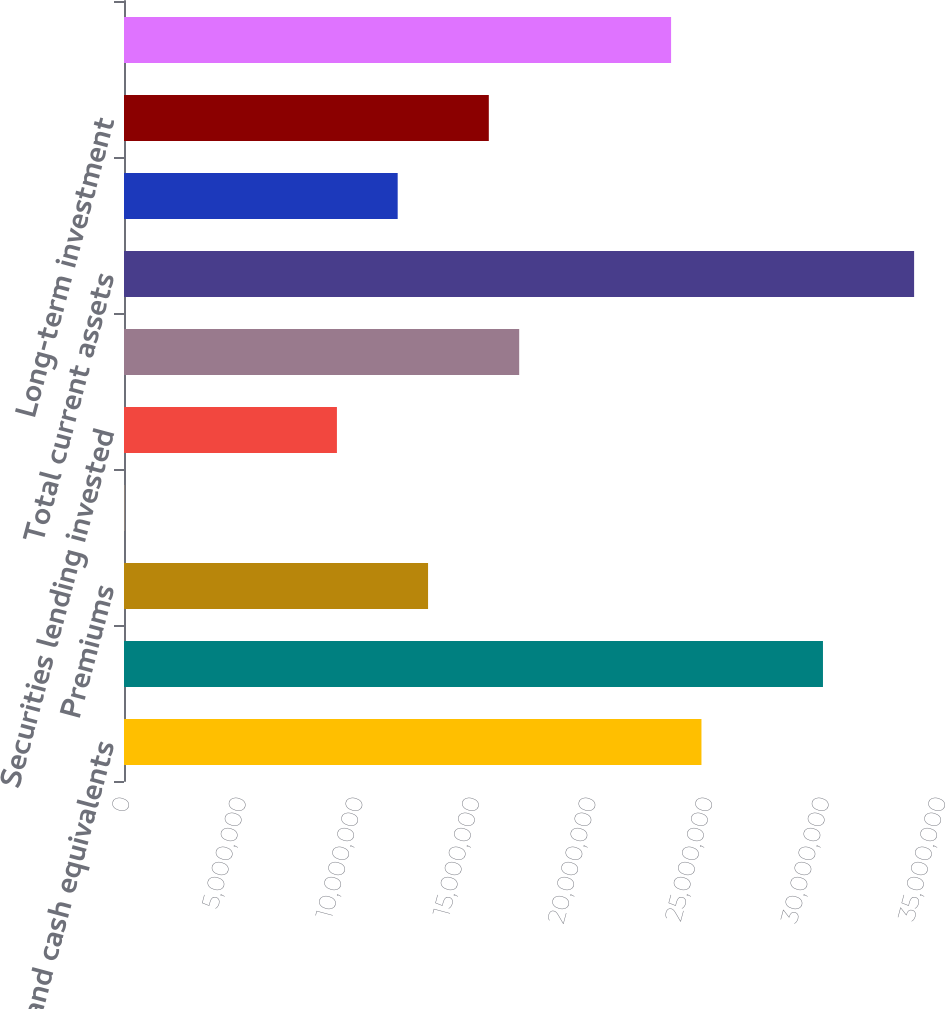Convert chart to OTSL. <chart><loc_0><loc_0><loc_500><loc_500><bar_chart><fcel>Cash and cash equivalents<fcel>Investment securities<fcel>Premiums<fcel>Administrative services fees<fcel>Securities lending invested<fcel>Other current assets<fcel>Total current assets<fcel>Property and equipment net<fcel>Long-term investment<fcel>Goodwill<nl><fcel>2.47685e+07<fcel>2.99804e+07<fcel>1.30418e+07<fcel>12010<fcel>9.13284e+06<fcel>1.69507e+07<fcel>3.38894e+07<fcel>1.17388e+07<fcel>1.56477e+07<fcel>2.34656e+07<nl></chart> 